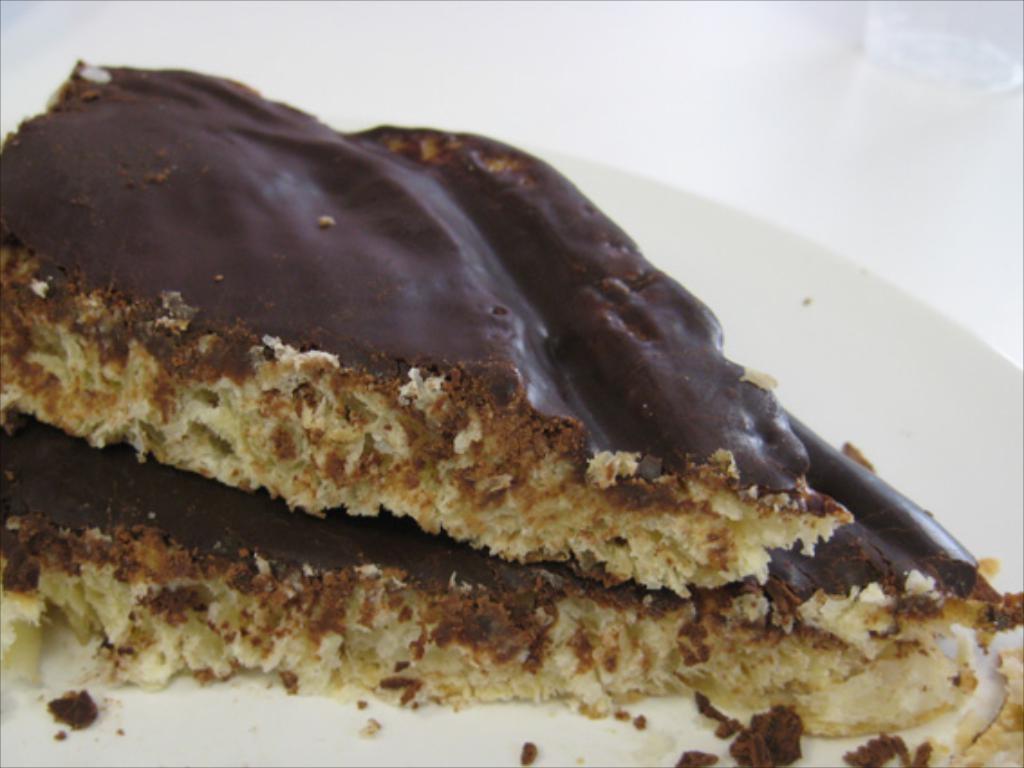Describe this image in one or two sentences. In this image I can see the food with plate. The plate is in white color and the food is in cream and brown color. 